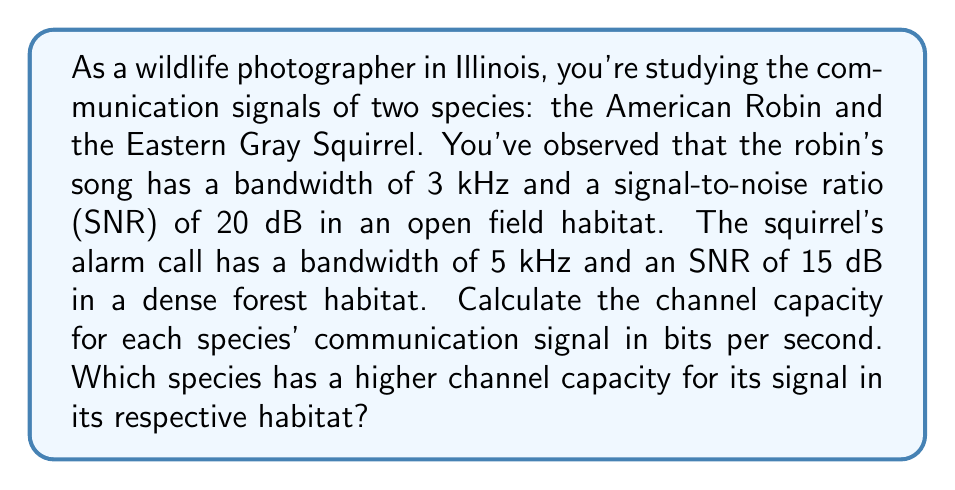Help me with this question. To solve this problem, we'll use the Shannon-Hartley theorem, which gives the channel capacity for a communication channel with Gaussian noise. The formula is:

$$ C = B \log_2(1 + SNR) $$

Where:
$C$ = channel capacity in bits per second
$B$ = bandwidth in Hz
$SNR$ = signal-to-noise ratio (linear, not dB)

Step 1: Convert SNR from dB to linear scale
For the American Robin: $SNR_{linear} = 10^{(20/10)} = 100$
For the Eastern Gray Squirrel: $SNR_{linear} = 10^{(15/10)} = 31.62$

Step 2: Calculate channel capacity for the American Robin
$$ C_{robin} = 3000 \log_2(1 + 100) = 3000 \log_2(101) $$
$$ C_{robin} = 3000 \cdot 6.658 = 19,974 \text{ bits/s} $$

Step 3: Calculate channel capacity for the Eastern Gray Squirrel
$$ C_{squirrel} = 5000 \log_2(1 + 31.62) = 5000 \log_2(32.62) $$
$$ C_{squirrel} = 5000 \cdot 5.028 = 25,140 \text{ bits/s} $$

Step 4: Compare the channel capacities
The Eastern Gray Squirrel has a higher channel capacity (25,140 bits/s) compared to the American Robin (19,974 bits/s) in their respective habitats.
Answer: American Robin: 19,974 bits/s
Eastern Gray Squirrel: 25,140 bits/s
The Eastern Gray Squirrel has a higher channel capacity for its signal in its habitat. 